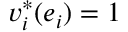<formula> <loc_0><loc_0><loc_500><loc_500>v _ { i } ^ { * } ( e _ { i } ) = 1</formula> 